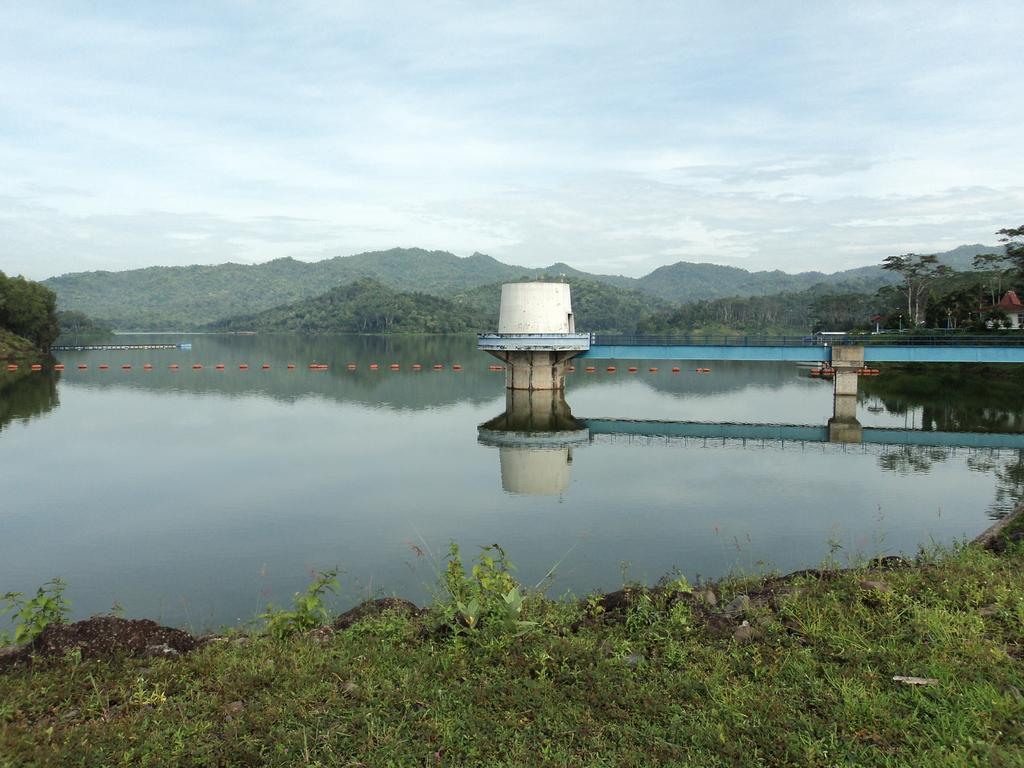Please provide a concise description of this image. This is an outside view. At the bottom of the image I can see the grass. In the middle of the image there is a river. On the right side, I can see a bridge. In the background there are many trees. At the top I can see the sky. 